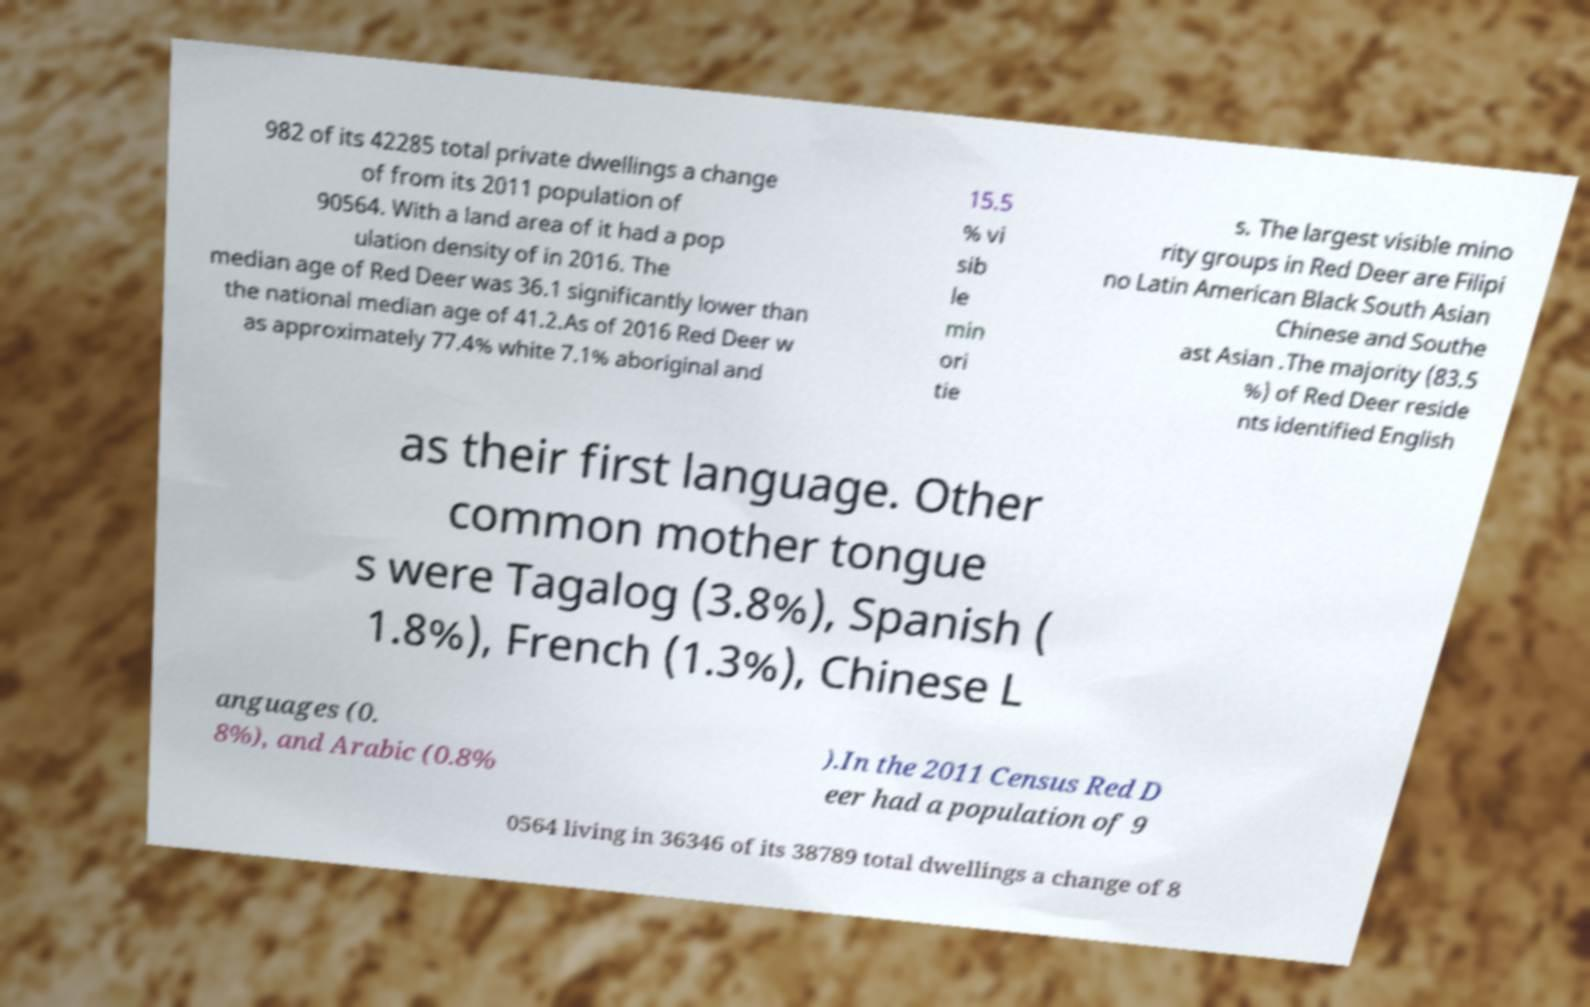Could you extract and type out the text from this image? 982 of its 42285 total private dwellings a change of from its 2011 population of 90564. With a land area of it had a pop ulation density of in 2016. The median age of Red Deer was 36.1 significantly lower than the national median age of 41.2.As of 2016 Red Deer w as approximately 77.4% white 7.1% aboriginal and 15.5 % vi sib le min ori tie s. The largest visible mino rity groups in Red Deer are Filipi no Latin American Black South Asian Chinese and Southe ast Asian .The majority (83.5 %) of Red Deer reside nts identified English as their first language. Other common mother tongue s were Tagalog (3.8%), Spanish ( 1.8%), French (1.3%), Chinese L anguages (0. 8%), and Arabic (0.8% ).In the 2011 Census Red D eer had a population of 9 0564 living in 36346 of its 38789 total dwellings a change of 8 